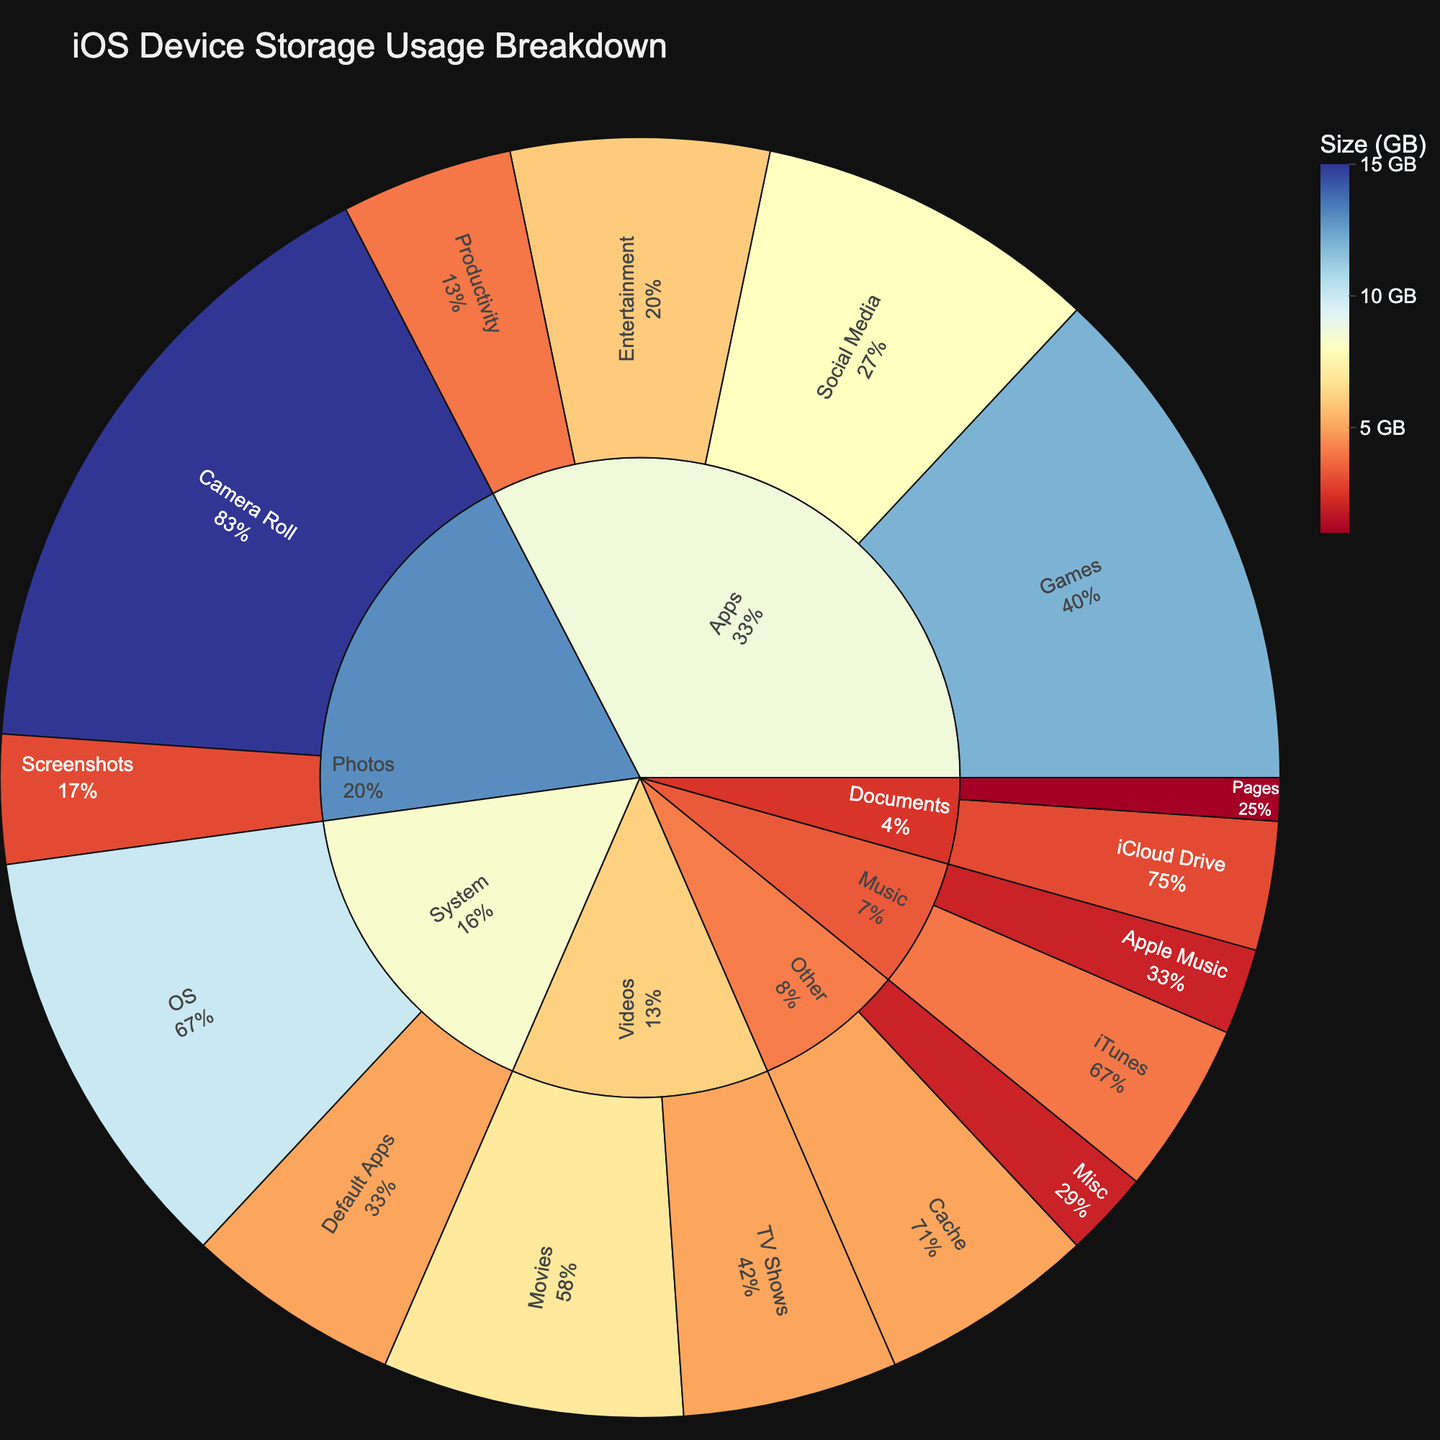How much storage is used by social media apps? Look at the "Social Media" section under the "Apps" category. The size listed is 8 GB.
Answer: 8 GB Which category uses the most storage? Identify the category with the largest proportion of the sunburst plot. The "Photos" category uses 18 GB (15 GB for Camera Roll and 3 GB for Screenshots), which is the largest.
Answer: Photos What is the total storage used by the System category? Sum the sizes of all subcategories under "System": OS (10 GB) + Default Apps (5 GB) = 15 GB.
Answer: 15 GB Which is larger, storage for games or storage for movies? Compare the sizes of "Games" (12 GB) and "Movies" (7 GB). 12 GB is larger than 7 GB.
Answer: Games How much storage is used by documents? Sum the sizes of all subcategories under "Documents": iCloud Drive (3 GB) + Pages (1 GB) = 4 GB.
Answer: 4 GB What percentage of storage does the Camera Roll take up compared to the total storage used for photos? The Camera Roll uses 15 GB, and the total storage for Photos is 18 GB. Percentage = (15 / 18) * 100 ≈ 83.3%.
Answer: 83.3% Which category has the smallest subcategory and what is it? Find the smallest size in the plot's subcategories. "Pages" within "Documents" uses 1 GB, which is the smallest.
Answer: Pages in Documents How does the storage for TV Shows compare to iTunes music storage? Compare "TV Shows" (5 GB) and "iTunes" (4 GB). TV Shows use more storage.
Answer: TV Shows What is the combined storage for all media formats (Photos, Videos, Music)? Sum the sizes of all subcategories under Photos (15 + 3), Videos (7 + 5), and Music (4 + 2). Total = 18 + 12 + 6 = 36 GB.
Answer: 36 GB Is the storage used by default apps greater than storage used by cloud drive? Compare "Default Apps" (5 GB) and "iCloud Drive" (3 GB). Default Apps use more storage.
Answer: Yes 